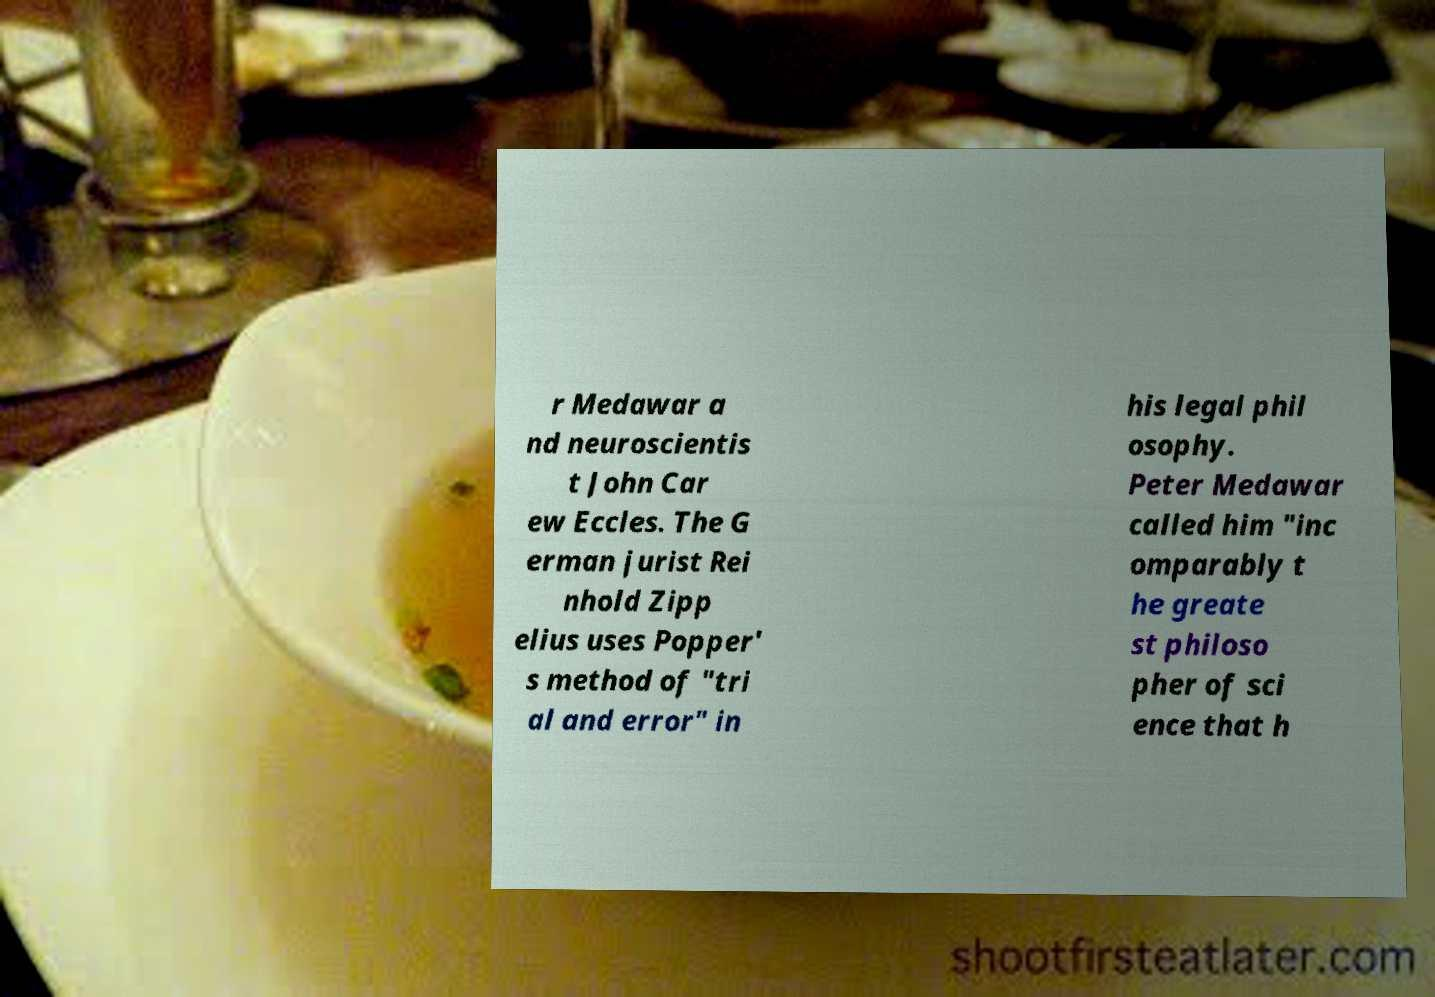I need the written content from this picture converted into text. Can you do that? r Medawar a nd neuroscientis t John Car ew Eccles. The G erman jurist Rei nhold Zipp elius uses Popper' s method of "tri al and error" in his legal phil osophy. Peter Medawar called him "inc omparably t he greate st philoso pher of sci ence that h 